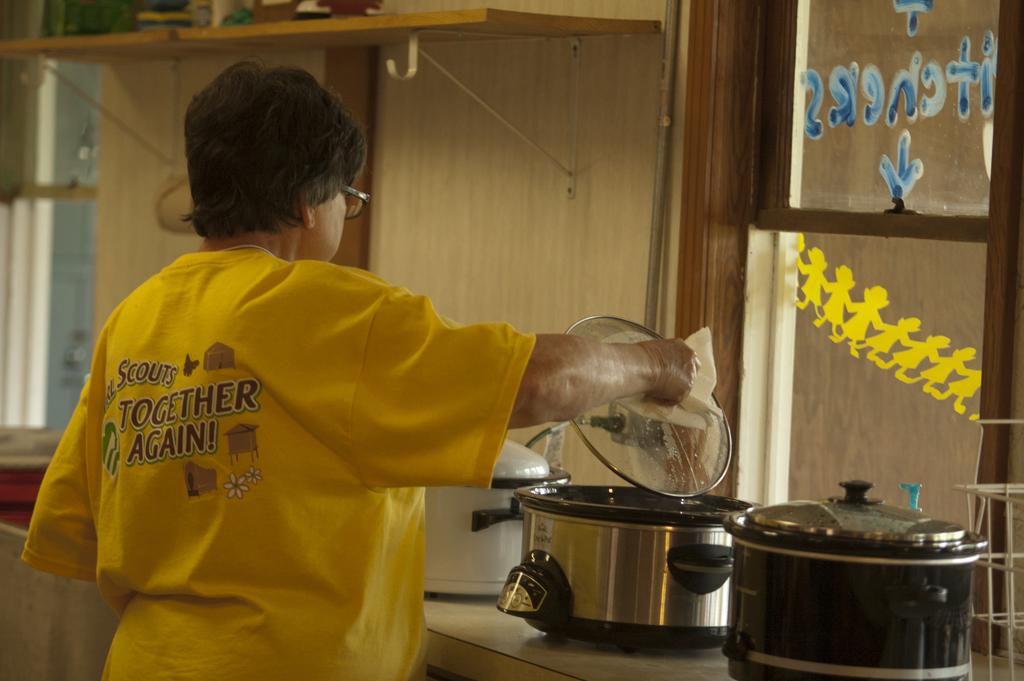Who are together again?
Your answer should be very brief. Scouts. 